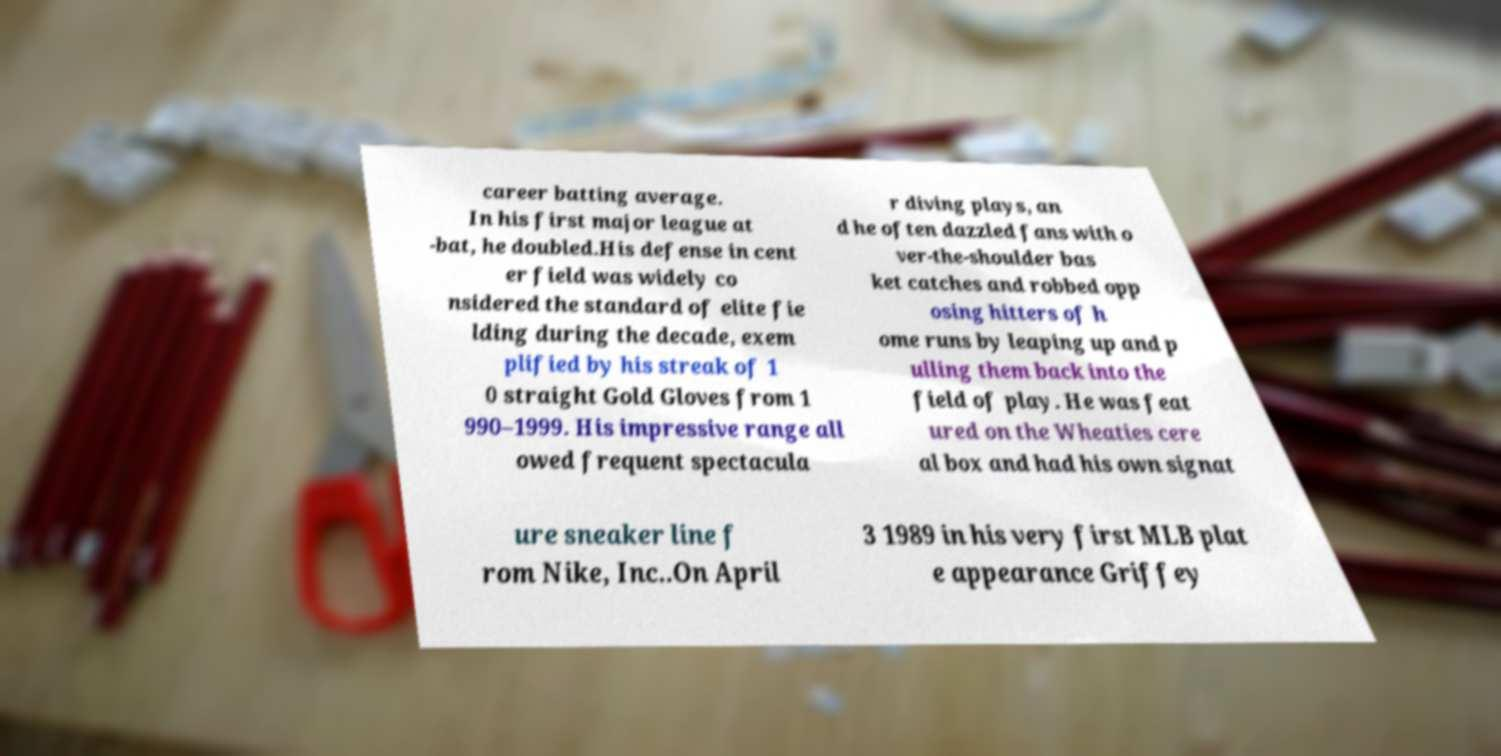What messages or text are displayed in this image? I need them in a readable, typed format. career batting average. In his first major league at -bat, he doubled.His defense in cent er field was widely co nsidered the standard of elite fie lding during the decade, exem plified by his streak of 1 0 straight Gold Gloves from 1 990–1999. His impressive range all owed frequent spectacula r diving plays, an d he often dazzled fans with o ver-the-shoulder bas ket catches and robbed opp osing hitters of h ome runs by leaping up and p ulling them back into the field of play. He was feat ured on the Wheaties cere al box and had his own signat ure sneaker line f rom Nike, Inc..On April 3 1989 in his very first MLB plat e appearance Griffey 